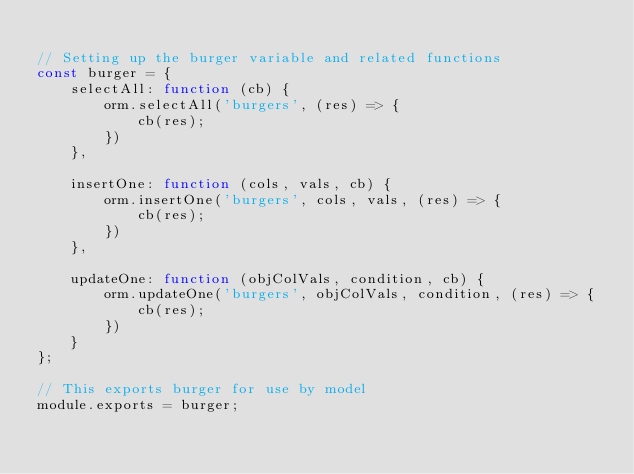<code> <loc_0><loc_0><loc_500><loc_500><_JavaScript_>
// Setting up the burger variable and related functions
const burger = {
    selectAll: function (cb) {
        orm.selectAll('burgers', (res) => {
            cb(res);
        })
    },

    insertOne: function (cols, vals, cb) {
        orm.insertOne('burgers', cols, vals, (res) => {
            cb(res);
        })
    },

    updateOne: function (objColVals, condition, cb) {
        orm.updateOne('burgers', objColVals, condition, (res) => {
            cb(res);
        })
    }
};

// This exports burger for use by model
module.exports = burger;</code> 